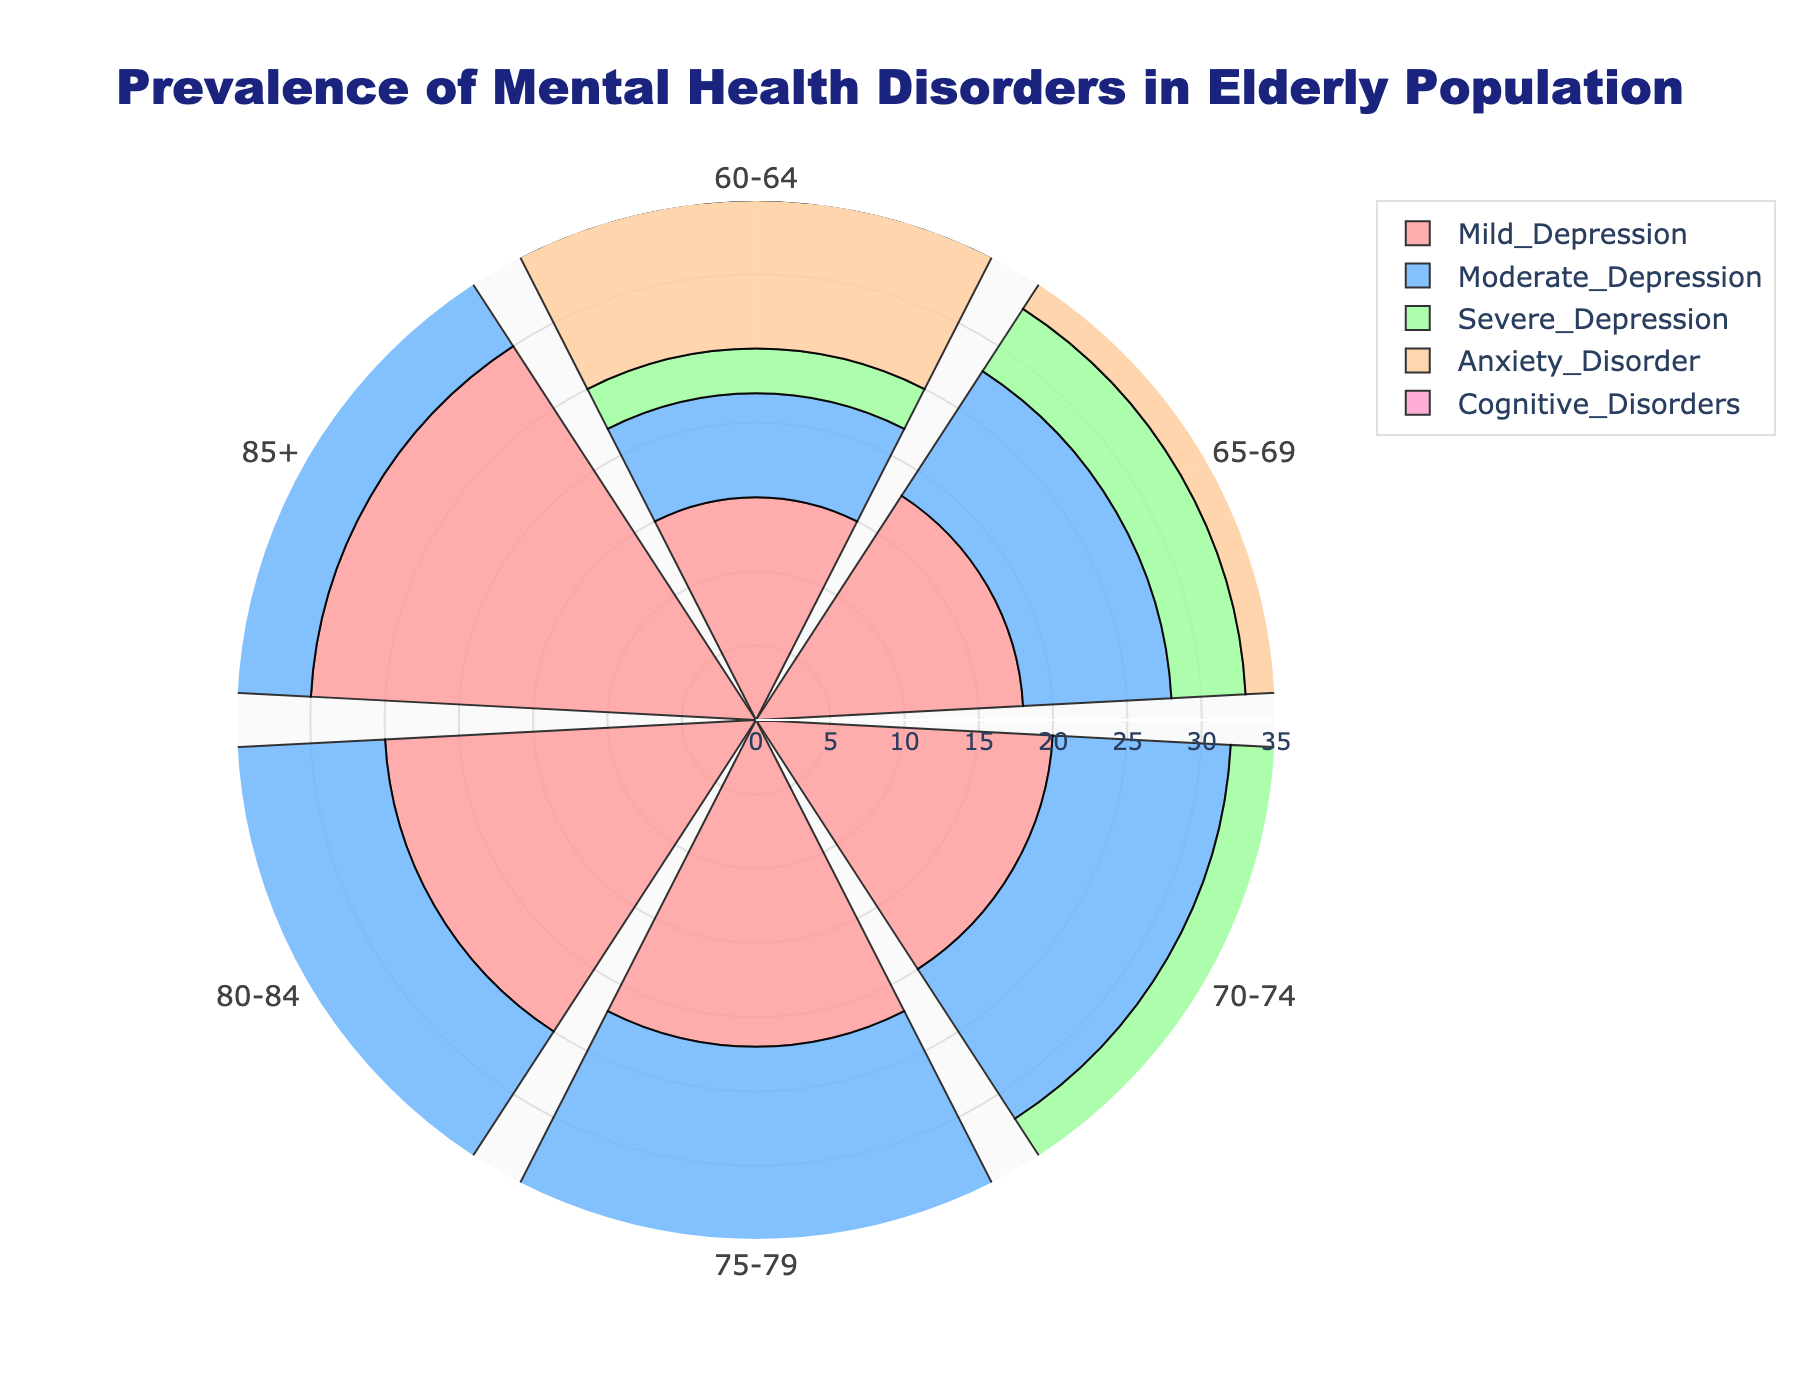What is the title of the figure? The title of the chart is displayed prominently at the top and provides context for the data being visualized.
Answer: Prevalence of Mental Health Disorders in Elderly Population How many different disorders are shown in the rose chart? The legend at the side of the chart displays the names and colors of the different disorders.
Answer: Five Which age group has the highest prevalence of anxiety disorder? By examining the section labeled "Anxiety Disorder" and comparing the bar lengths across age groups, you can see the longest bar in the "85+" category.
Answer: 85+ What is the average prevalence of severe depression across all age groups? To find the average, add the prevalence values of severe depression for all age groups and divide by the number of age groups. (3 + 5 + 6 + 8 + 10 + 12) = 44, then 44/6 = 7.33
Answer: 7.33 Compare the prevalence of mild depression between the 60-64 and 85+ age groups. By looking at the "Mild Depression" sections for the age groups 60-64 and 85+, it is clear that 15 is less than 30.
Answer: The 85+ age group has a higher prevalence Which disorder has the least variation in prevalence among different age groups? Check the bar lengths for each disorder across all age groups. Cognitive Disorders has the least fluctuation in length.
Answer: Cognitive Disorders What age group has the lowest prevalence of cognitive disorders? By examining the "Cognitive Disorders" section of the rose chart, the 60-64 age group has the smallest bar length.
Answer: 60-64 Which disorder has the highest overall prevalence in the "70-74" age group? The tallest bar representing this age group in the rose chart is for Anxiety Disorder.
Answer: Anxiety Disorder How does the prevalence of moderate depression for the 75-79 age group compare to the 80-84 age group? By comparing the bar lengths for moderate depression, the 80-84 age group is slightly higher with a value of 16 compared to 14 for the 75-79 age group.
Answer: The 80-84 age group has a higher prevalence What is the total prevalence of mental health disorders for the "65-69" age group? Sum the prevalence values of all disorders in the 65-69 age group: 18 + 10 + 5 + 12 + 8 = 53.
Answer: 53 